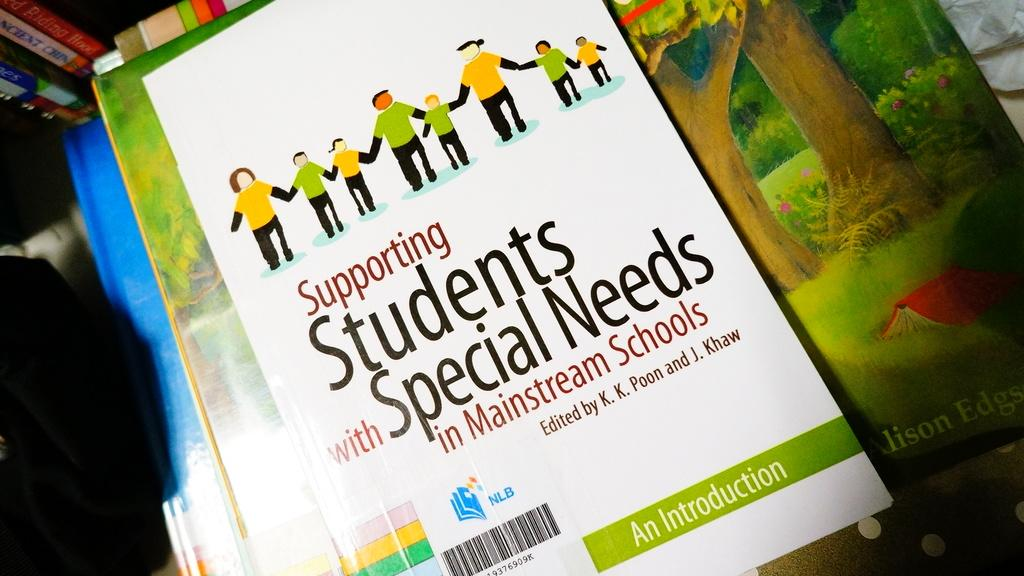What type of books are visible in the image? There are books in the image. What type of engine is powering the sun in the image? There is no engine or sun present in the image; it only features books. 